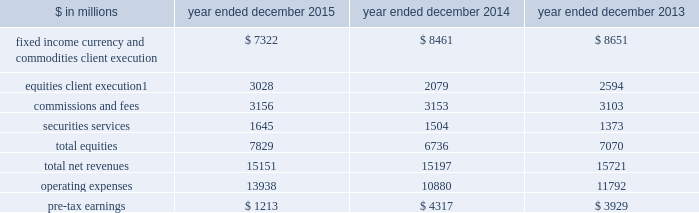The goldman sachs group , inc .
And subsidiaries management 2019s discussion and analysis equities .
Includes client execution activities related to making markets in equity products and commissions and fees from executing and clearing institutional client transactions on major stock , options and futures exchanges worldwide , as well as otc transactions .
Equities also includes our securities services business , which provides financing , securities lending and other prime brokerage services to institutional clients , including hedge funds , mutual funds , pension funds and foundations , and generates revenues primarily in the form of interest rate spreads or fees .
The table below presents the operating results of our institutional client services segment. .
Net revenues related to the americas reinsurance business were $ 317 million for 2013 .
In april 2013 , we completed the sale of a majority stake in our americas reinsurance business and no longer consolidate this business .
2015 versus 2014 .
Net revenues in institutional client services were $ 15.15 billion for 2015 , essentially unchanged compared with 2014 .
Net revenues in fixed income , currency and commodities client execution were $ 7.32 billion for 2015 , 13% ( 13 % ) lower than 2014 .
Excluding a gain of $ 168 million in 2014 related to the extinguishment of certain of our junior subordinated debt , net revenues in fixed income , currency and commodities client execution were 12% ( 12 % ) lower than 2014 , reflecting significantly lower net revenues in mortgages , credit products and commodities .
The decreases in mortgages and credit products reflected challenging market-making conditions and generally low levels of activity during 2015 .
The decline in commodities primarily reflected less favorable market-making conditions compared with 2014 , which included a strong first quarter of 2014 .
These decreases were partially offset by significantly higher net revenues in interest rate products and currencies , reflecting higher volatility levels which contributed to higher client activity levels , particularly during the first quarter of 2015 .
Net revenues in equities were $ 7.83 billion for 2015 , 16% ( 16 % ) higher than 2014 .
Excluding a gain of $ 121 million ( $ 30 million and $ 91 million included in equities client execution and securities services , respectively ) in 2014 related to the extinguishment of certain of our junior subordinated debt , net revenues in equities were 18% ( 18 % ) higher than 2014 , primarily due to significantly higher net revenues in equities client execution across the major regions , reflecting significantly higher results in both derivatives and cash products , and higher net revenues in securities services , reflecting the impact of higher average customer balances and improved securities lending spreads .
Commissions and fees were essentially unchanged compared with 2014 .
The firm elects the fair value option for certain unsecured borrowings .
The fair value net gain attributable to the impact of changes in our credit spreads on these borrowings was $ 255 million ( $ 214 million and $ 41 million related to fixed income , currency and commodities client execution and equities client execution , respectively ) for 2015 , compared with a net gain of $ 144 million ( $ 108 million and $ 36 million related to fixed income , currency and commodities client execution and equities client execution , respectively ) for 2014 .
During 2015 , the operating environment for institutional client services was positively impacted by diverging central bank monetary policies in the united states and the euro area in the first quarter , as increased volatility levels contributed to strong client activity levels in currencies , interest rate products and equity products , and market- making conditions improved .
However , during the remainder of the year , concerns about global growth and uncertainty about the u.s .
Federal reserve 2019s interest rate policy , along with lower global equity prices , widening high-yield credit spreads and declining commodity prices , contributed to lower levels of client activity , particularly in mortgages and credit , and more difficult market-making conditions .
If macroeconomic concerns continue over the long term and activity levels decline , net revenues in institutional client services would likely be negatively impacted .
Operating expenses were $ 13.94 billion for 2015 , 28% ( 28 % ) higher than 2014 , due to significantly higher net provisions for mortgage-related litigation and regulatory matters , partially offset by decreased compensation and benefits expenses .
Pre-tax earnings were $ 1.21 billion in 2015 , 72% ( 72 % ) lower than 2014 .
62 goldman sachs 2015 form 10-k .
What percentage of total net revenues in the institutional client services segment was due to fixed income currency and commodities client execution in 2015? 
Computations: (7322 / 15151)
Answer: 0.48327. 